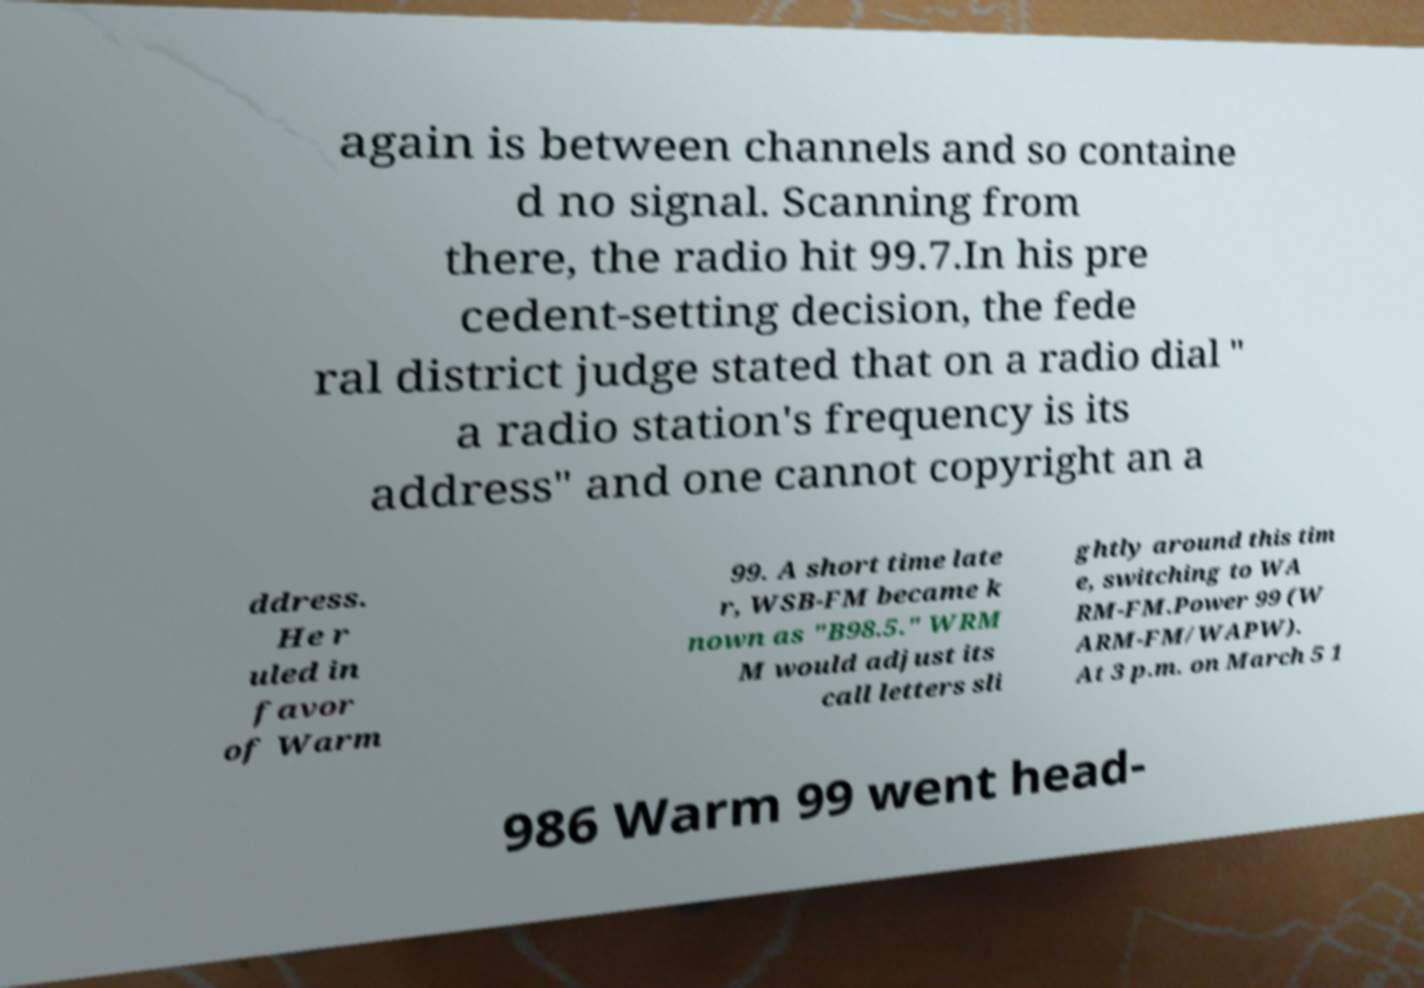Could you assist in decoding the text presented in this image and type it out clearly? again is between channels and so containe d no signal. Scanning from there, the radio hit 99.7.In his pre cedent-setting decision, the fede ral district judge stated that on a radio dial " a radio station's frequency is its address" and one cannot copyright an a ddress. He r uled in favor of Warm 99. A short time late r, WSB-FM became k nown as "B98.5." WRM M would adjust its call letters sli ghtly around this tim e, switching to WA RM-FM.Power 99 (W ARM-FM/WAPW). At 3 p.m. on March 5 1 986 Warm 99 went head- 